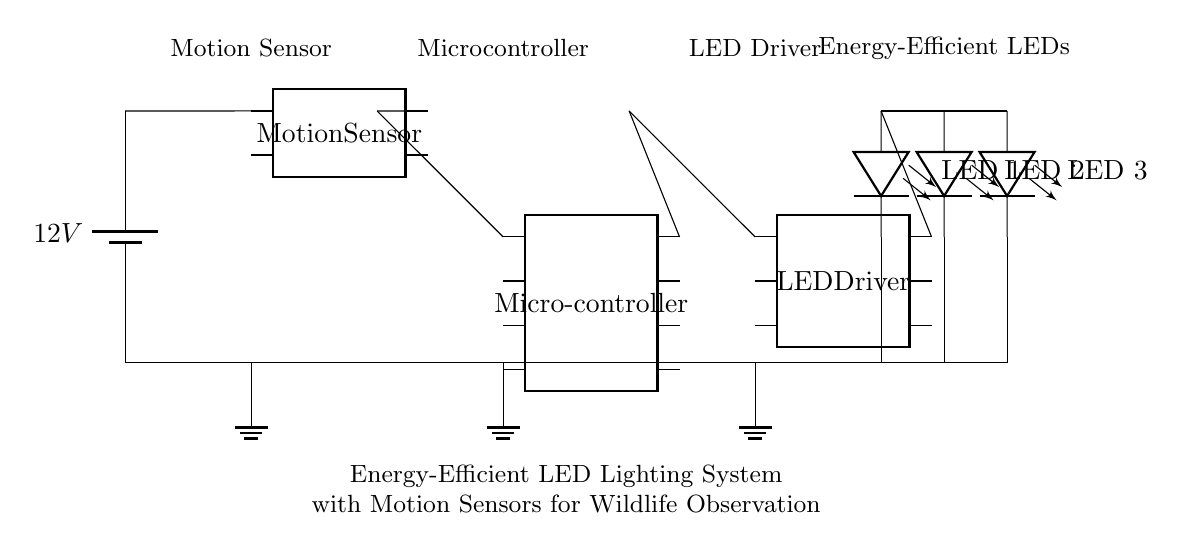What is the voltage of the power source? The circuit shows a battery marked with a voltage of 12V, indicating the potential difference it provides.
Answer: 12V How many LEDs are in this circuit? The diagram displays three LED symbols connected in series, indicating the use of three individual LEDs for lighting.
Answer: 3 What component detects motion in this circuit? The circuit includes a device labeled as a "Motion Sensor," which is responsible for detecting movement.
Answer: Motion Sensor What is the role of the microcontroller in this circuit? The microcontroller is connected to the motion sensor and LED driver, indicating its role in processing the motion feedback and controlling the LED lights accordingly.
Answer: Control What happens when motion is detected? When the motion sensor detects movement, it sends a signal to the microcontroller, which in turn activates the LED driver to power the LEDs, illuminating the area.
Answer: LEDs illuminate What is the connection between the motion sensor and the microcontroller? The motion sensor's output pin is directly connected to one of the input pins on the microcontroller, enabling data transfer for processing motion information.
Answer: Direct connection Which component provides power to the LEDs? The LED driver, which is connected to the power source and the LEDs, regulates and supplies the necessary current to light the LEDs effectively.
Answer: LED Driver 